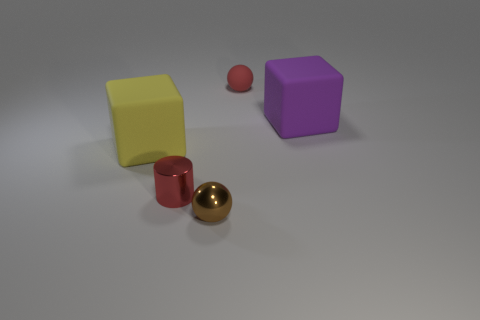Add 4 large gray cubes. How many objects exist? 9 Subtract all balls. How many objects are left? 3 Subtract all big yellow things. Subtract all purple things. How many objects are left? 3 Add 5 brown things. How many brown things are left? 6 Add 3 matte objects. How many matte objects exist? 6 Subtract 0 blue cubes. How many objects are left? 5 